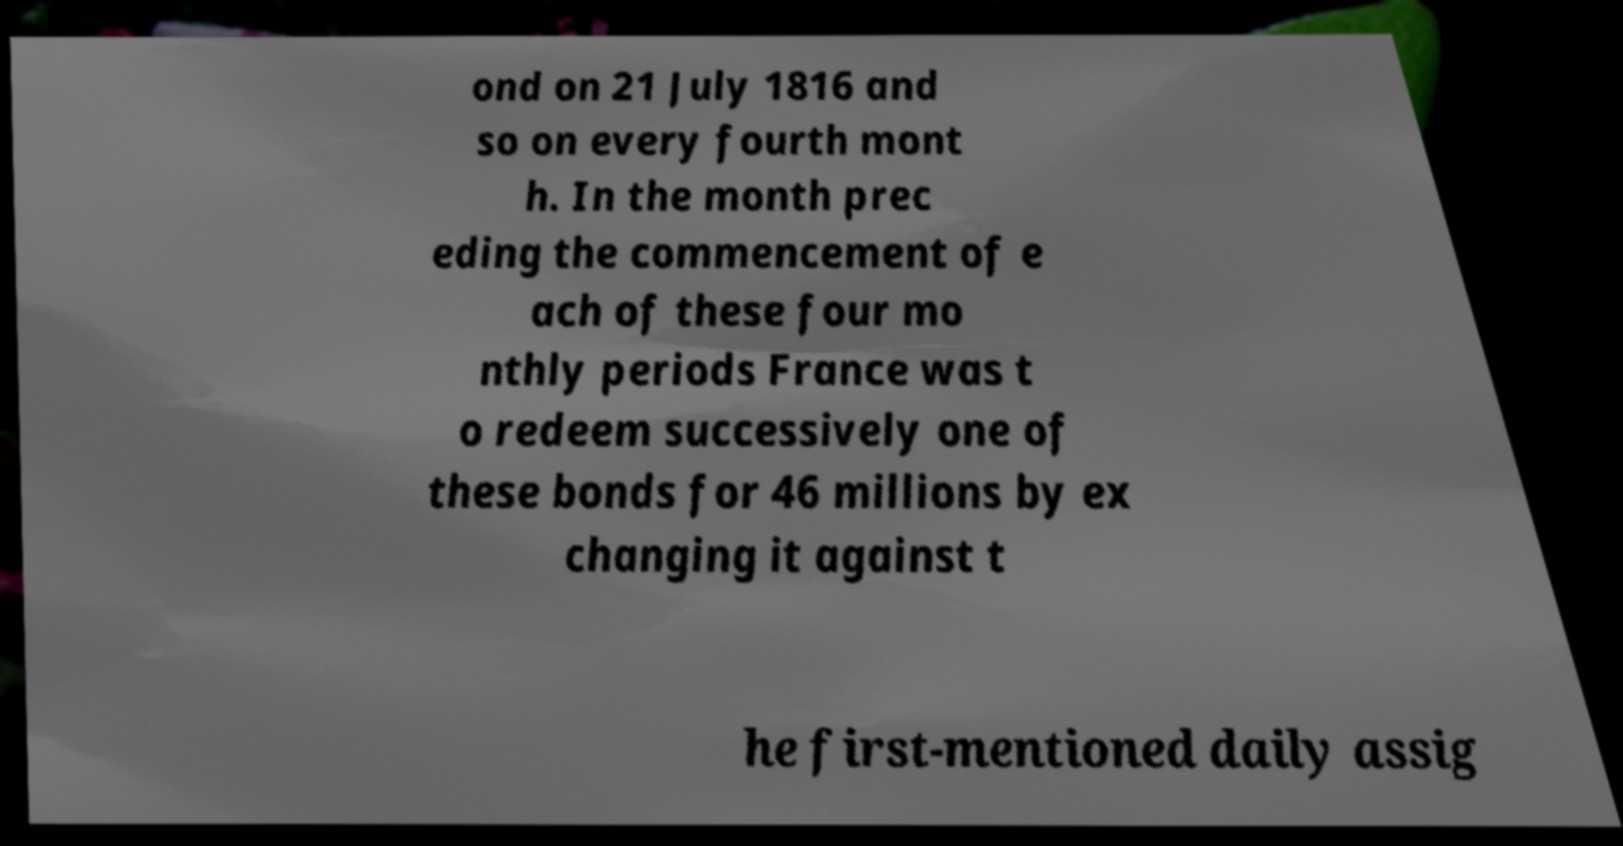What messages or text are displayed in this image? I need them in a readable, typed format. ond on 21 July 1816 and so on every fourth mont h. In the month prec eding the commencement of e ach of these four mo nthly periods France was t o redeem successively one of these bonds for 46 millions by ex changing it against t he first-mentioned daily assig 